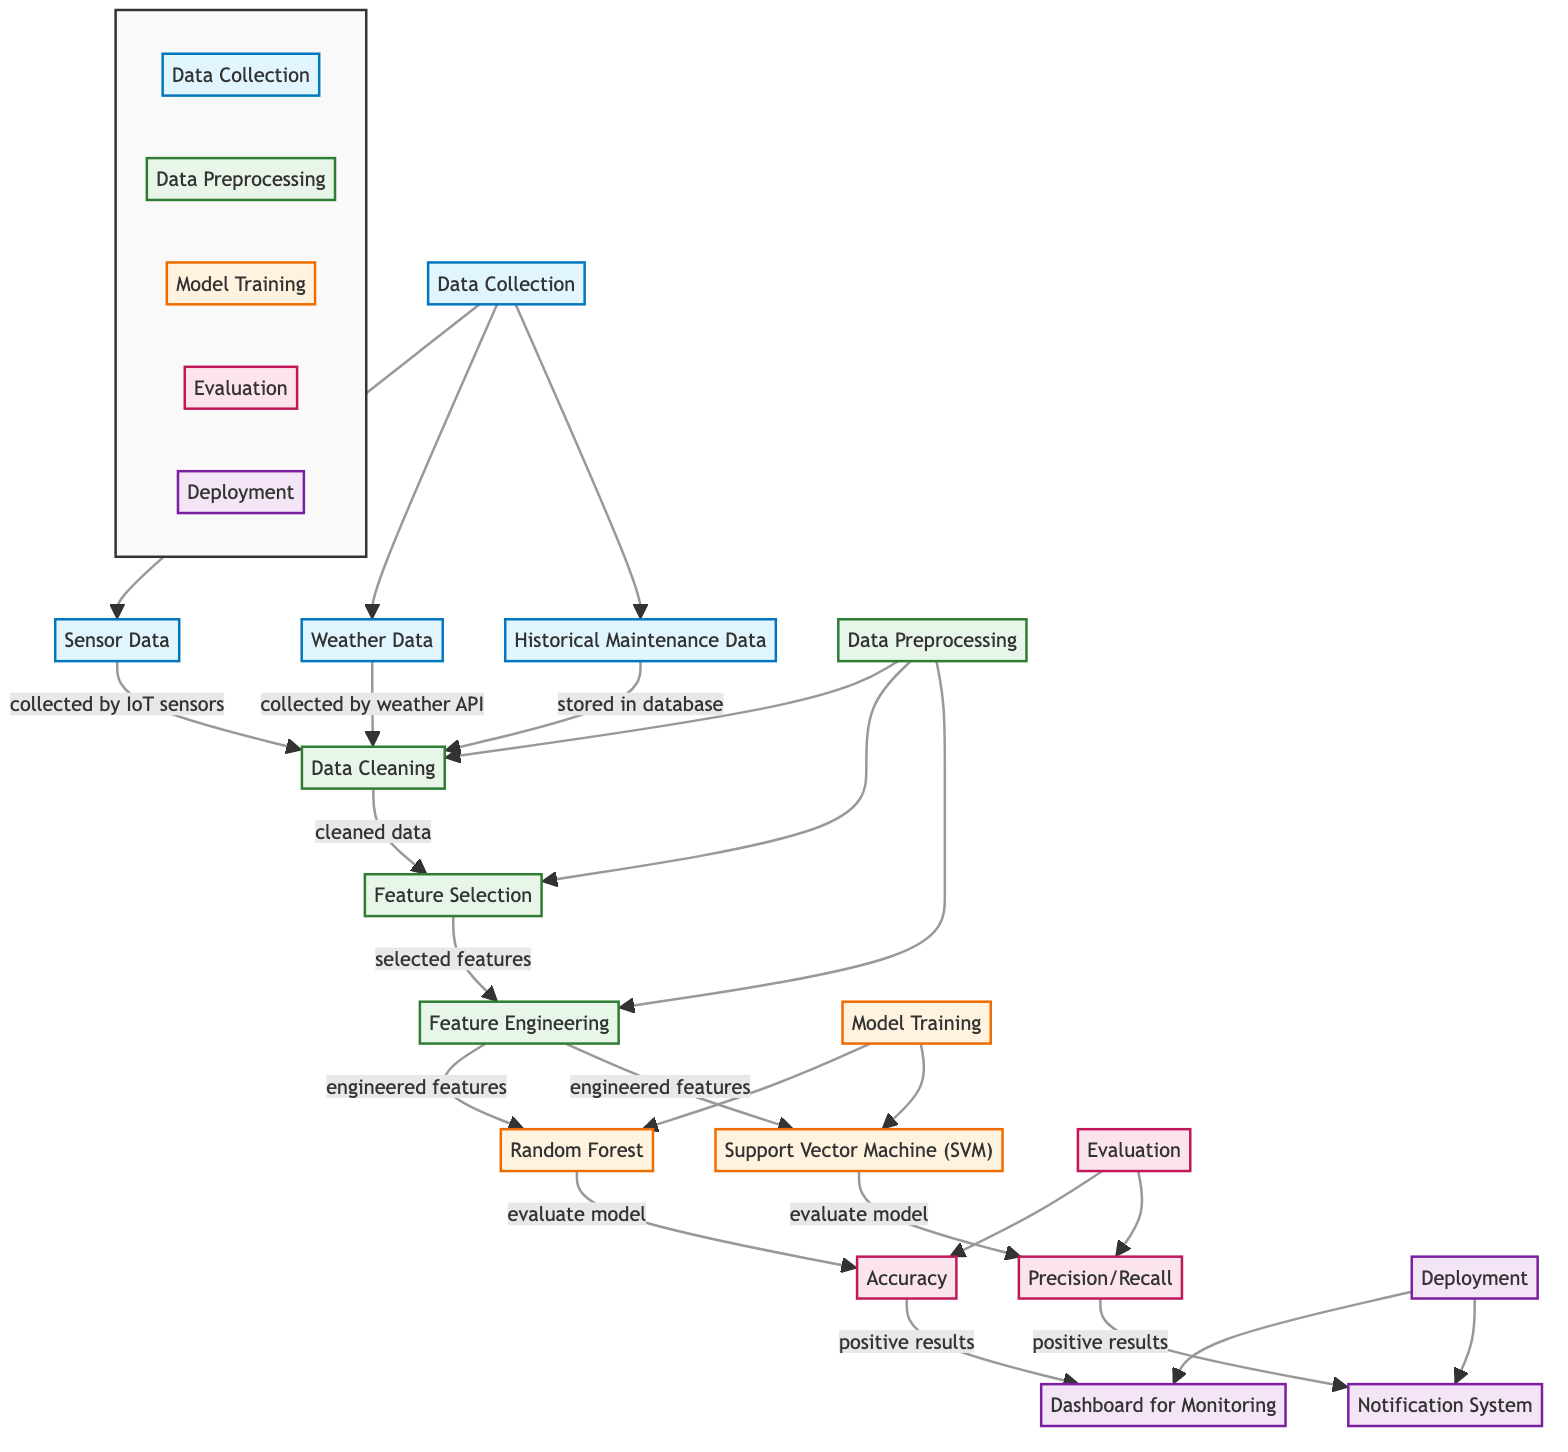What types of data are collected in the diagram? The diagram includes three types of data: Sensor Data, Weather Data, and Historical Maintenance Data. Each type is indicated clearly in the Data Collection node, showing what inputs are gathered for analysis.
Answer: Sensor Data, Weather Data, Historical Maintenance Data How many modeling techniques are mentioned in the diagram? The diagram explicitly lists two modeling techniques: Random Forest and Support Vector Machine (SVM) under the Model Training node. This indicates that there are two primary approaches being utilized for this machine learning application.
Answer: 2 What is the outcome of the Random Forest node? The outcome from the Random Forest node leads to the Accuracy evaluation node, indicating that the model's effectiveness is gauged through accuracy measurement after model training.
Answer: Accuracy What is the relationship between Data Preprocessing and Feature Selection? Data Preprocessing involves several steps including Data Cleaning, which produces cleaned data to be fed into the Feature Selection process, thus establishing a direct relationship between these two nodes.
Answer: DataCleaning → FeatureSelection What are the two deployment outcomes represented in the diagram? Following the evaluation phase, the two deployment outcomes are the Dashboard for Monitoring and the Notification System, which provide real-time feedback and alerts based on model evaluations.
Answer: Dashboard for Monitoring, Notification System How does Weather Data contribute to the flow? Weather Data is collected via an API, then cleaned, and subsequently processed in Data Cleaning. It serves as an input for further preprocessing and training of machine learning models aiding in predictive maintenance.
Answer: Processed through DataCleaning Which two evaluations follow the model training? The two evaluations that follow the model training are Accuracy and Precision/Recall, which assess the model effectiveness based on different criteria after training with the data from the chosen modeling techniques.
Answer: Accuracy, Precision/Recall What are the final outputs of the evaluation stage? The final outputs of the evaluation stage are linked to the Dashboard and Notification System, showing that the model's results are communicated through these outputs for user-facing applications.
Answer: Dashboard, Notification System What does the Notification System indicate according to the diagram? The Notification System takes positive results from the Precision/Recall evaluation, indicating that it likely functions to alert users regarding maintenance needs or performance issues of the solar panels based on the model’s predictions.
Answer: Positive results from PrecisionRecall 